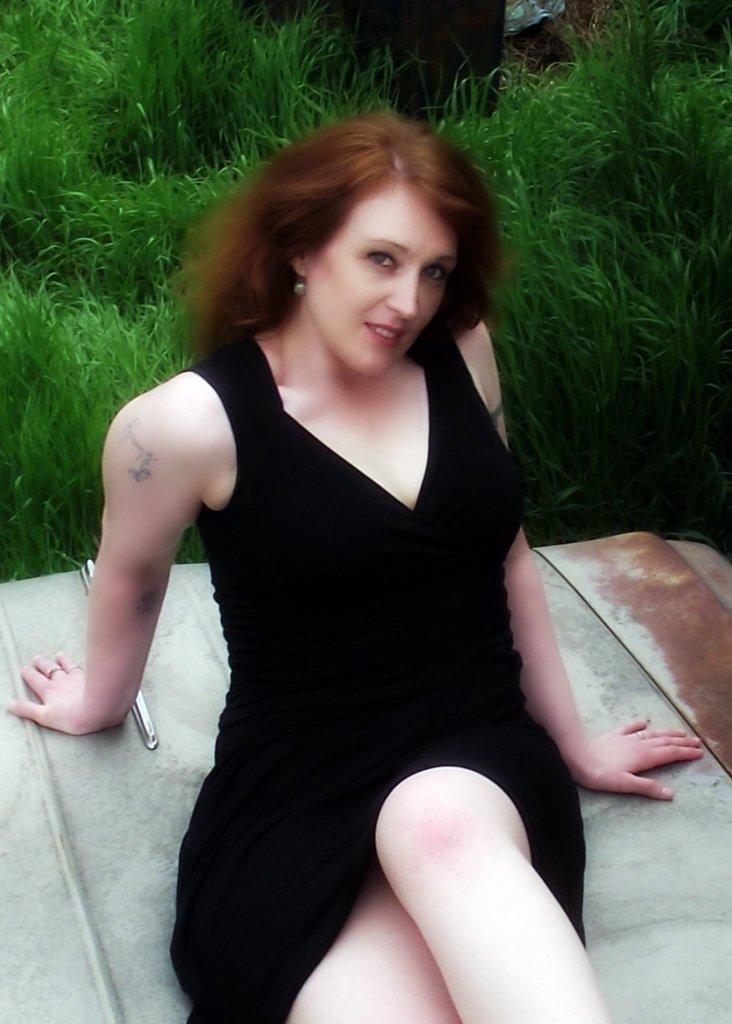How would you summarize this image in a sentence or two? In this picture we can see a women wearing black color top, lying on the car bonnet, smiling and giving a pose in the camera. Behind there is a grass. 